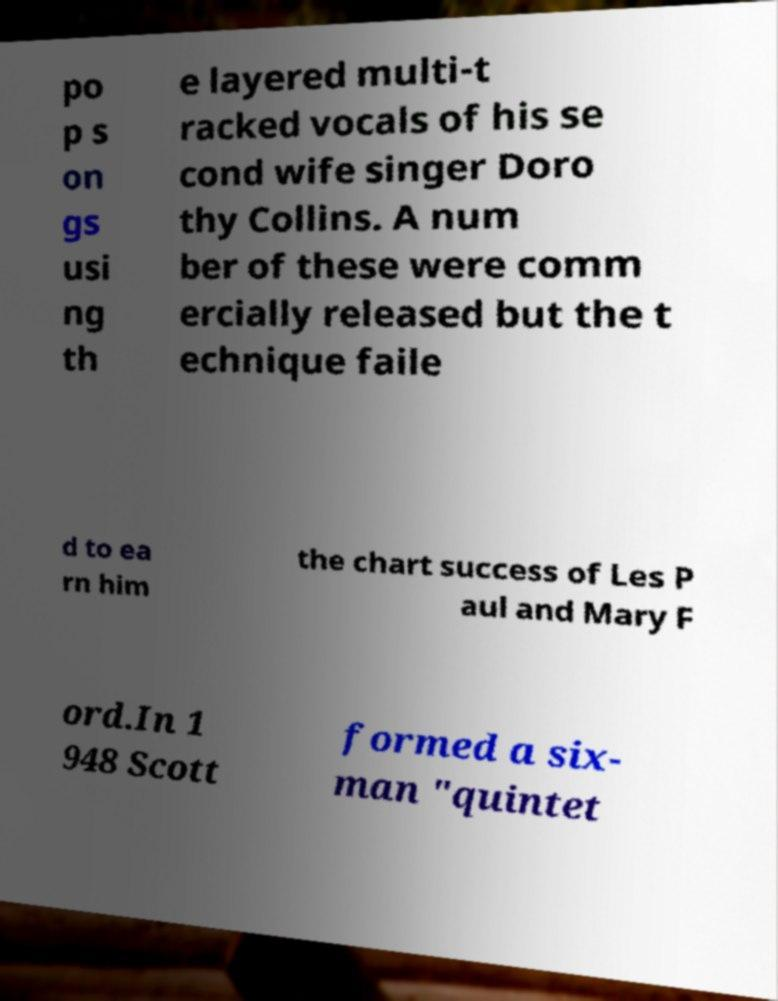Can you read and provide the text displayed in the image?This photo seems to have some interesting text. Can you extract and type it out for me? po p s on gs usi ng th e layered multi-t racked vocals of his se cond wife singer Doro thy Collins. A num ber of these were comm ercially released but the t echnique faile d to ea rn him the chart success of Les P aul and Mary F ord.In 1 948 Scott formed a six- man "quintet 